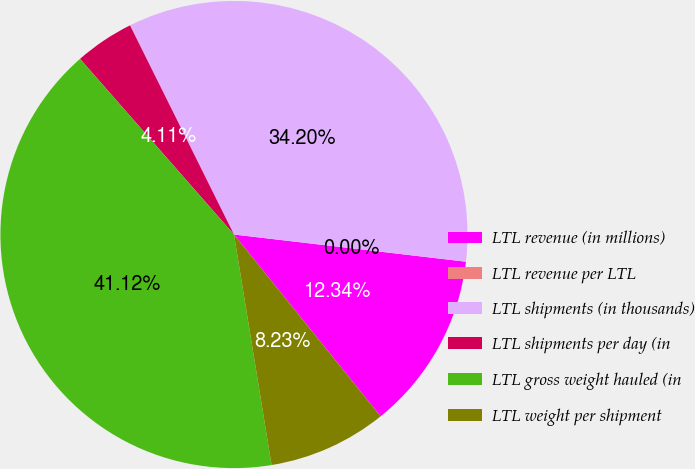Convert chart. <chart><loc_0><loc_0><loc_500><loc_500><pie_chart><fcel>LTL revenue (in millions)<fcel>LTL revenue per LTL<fcel>LTL shipments (in thousands)<fcel>LTL shipments per day (in<fcel>LTL gross weight hauled (in<fcel>LTL weight per shipment<nl><fcel>12.34%<fcel>0.0%<fcel>34.2%<fcel>4.11%<fcel>41.12%<fcel>8.23%<nl></chart> 